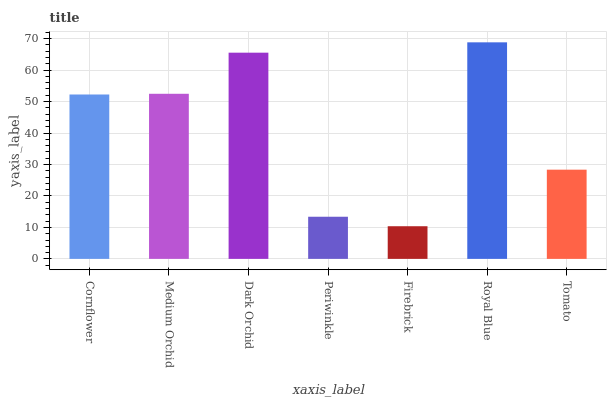Is Firebrick the minimum?
Answer yes or no. Yes. Is Royal Blue the maximum?
Answer yes or no. Yes. Is Medium Orchid the minimum?
Answer yes or no. No. Is Medium Orchid the maximum?
Answer yes or no. No. Is Medium Orchid greater than Cornflower?
Answer yes or no. Yes. Is Cornflower less than Medium Orchid?
Answer yes or no. Yes. Is Cornflower greater than Medium Orchid?
Answer yes or no. No. Is Medium Orchid less than Cornflower?
Answer yes or no. No. Is Cornflower the high median?
Answer yes or no. Yes. Is Cornflower the low median?
Answer yes or no. Yes. Is Medium Orchid the high median?
Answer yes or no. No. Is Dark Orchid the low median?
Answer yes or no. No. 